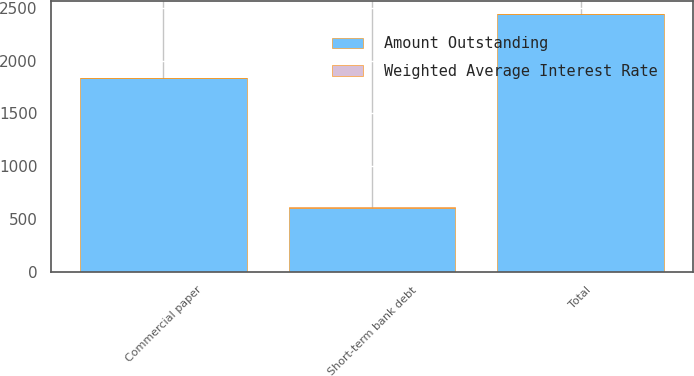<chart> <loc_0><loc_0><loc_500><loc_500><stacked_bar_chart><ecel><fcel>Commercial paper<fcel>Short-term bank debt<fcel>Total<nl><fcel>Amount Outstanding<fcel>1832<fcel>607<fcel>2439<nl><fcel>Weighted Average Interest Rate<fcel>1.8<fcel>2.3<fcel>1.9<nl></chart> 